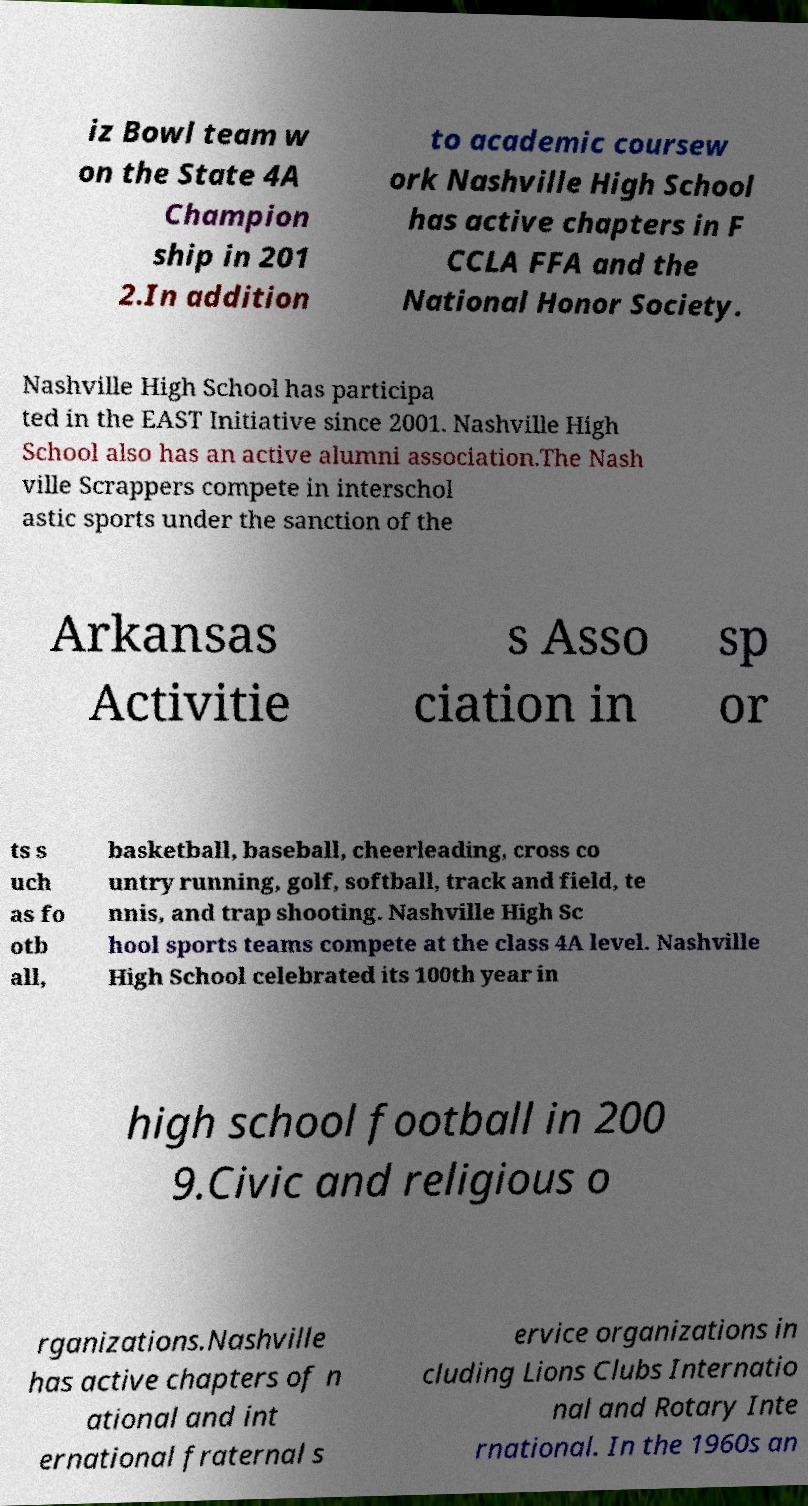For documentation purposes, I need the text within this image transcribed. Could you provide that? iz Bowl team w on the State 4A Champion ship in 201 2.In addition to academic coursew ork Nashville High School has active chapters in F CCLA FFA and the National Honor Society. Nashville High School has participa ted in the EAST Initiative since 2001. Nashville High School also has an active alumni association.The Nash ville Scrappers compete in interschol astic sports under the sanction of the Arkansas Activitie s Asso ciation in sp or ts s uch as fo otb all, basketball, baseball, cheerleading, cross co untry running, golf, softball, track and field, te nnis, and trap shooting. Nashville High Sc hool sports teams compete at the class 4A level. Nashville High School celebrated its 100th year in high school football in 200 9.Civic and religious o rganizations.Nashville has active chapters of n ational and int ernational fraternal s ervice organizations in cluding Lions Clubs Internatio nal and Rotary Inte rnational. In the 1960s an 